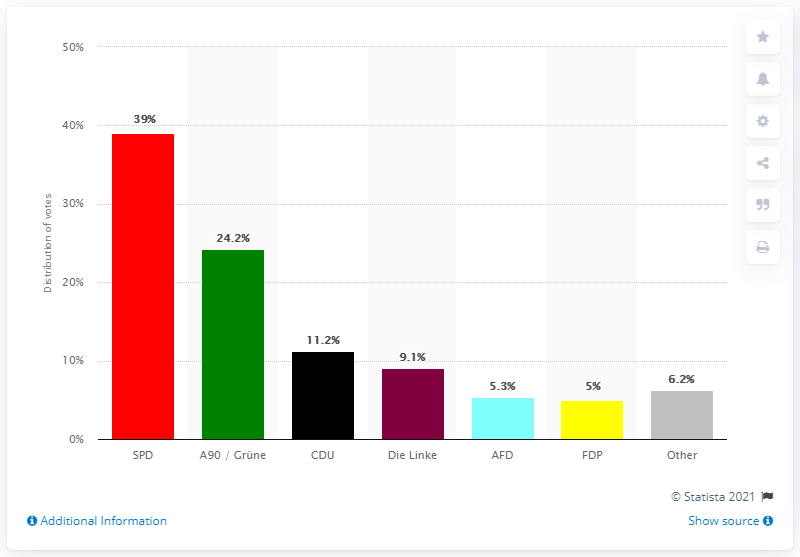List a handful of essential elements in this visual. Angela Merkel's CDU received 11.2% of the vote in an election. 